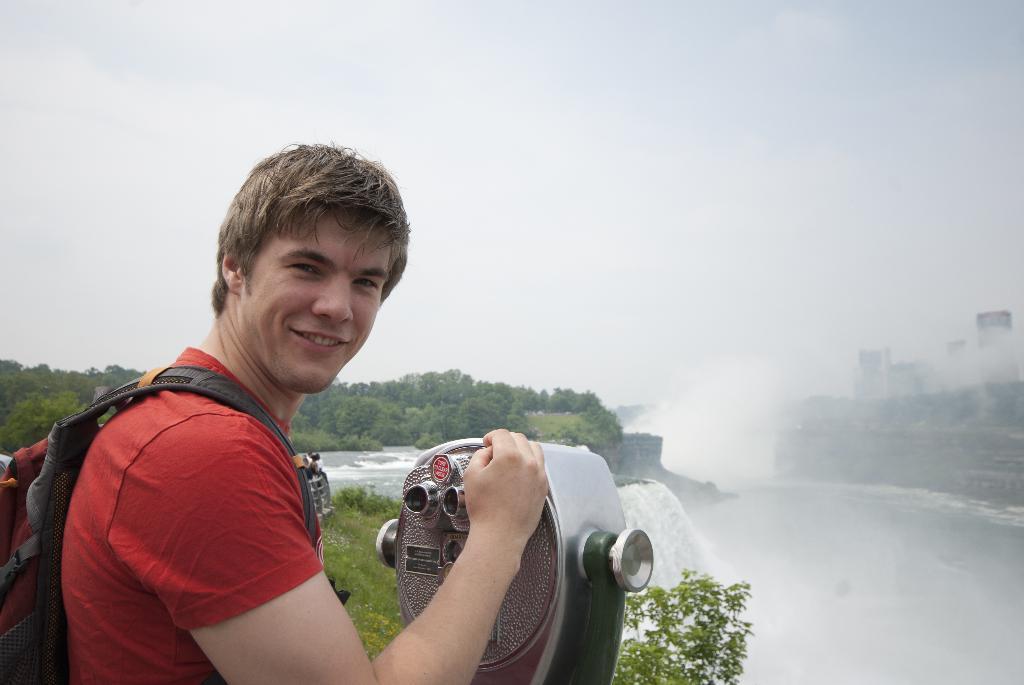In one or two sentences, can you explain what this image depicts? In this picture we can see a man standing and smiling, on the right side there is water, we can see trees in the background, there is the sky at the top of the picture, this man is carrying a backpack. 